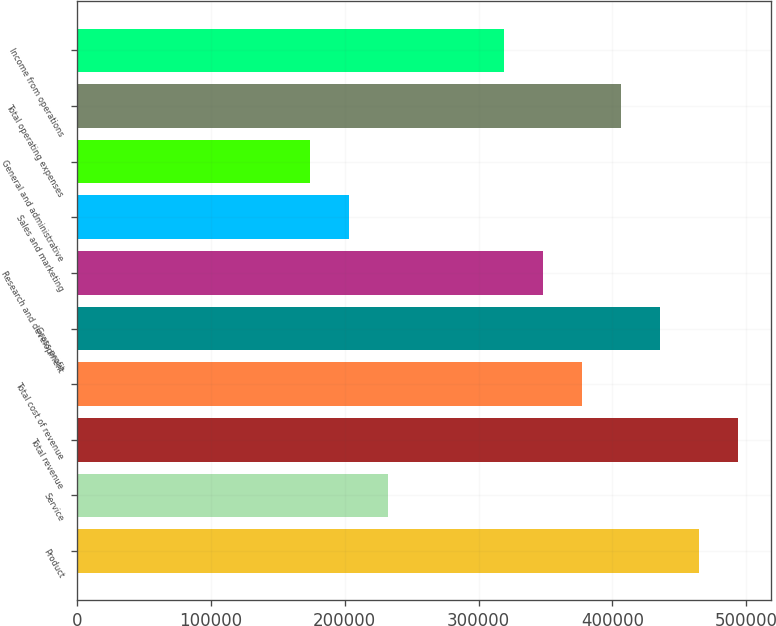Convert chart to OTSL. <chart><loc_0><loc_0><loc_500><loc_500><bar_chart><fcel>Product<fcel>Service<fcel>Total revenue<fcel>Total cost of revenue<fcel>Gross profit<fcel>Research and development<fcel>Sales and marketing<fcel>General and administrative<fcel>Total operating expenses<fcel>Income from operations<nl><fcel>464417<fcel>232209<fcel>493443<fcel>377339<fcel>435391<fcel>348313<fcel>203183<fcel>174157<fcel>406365<fcel>319287<nl></chart> 